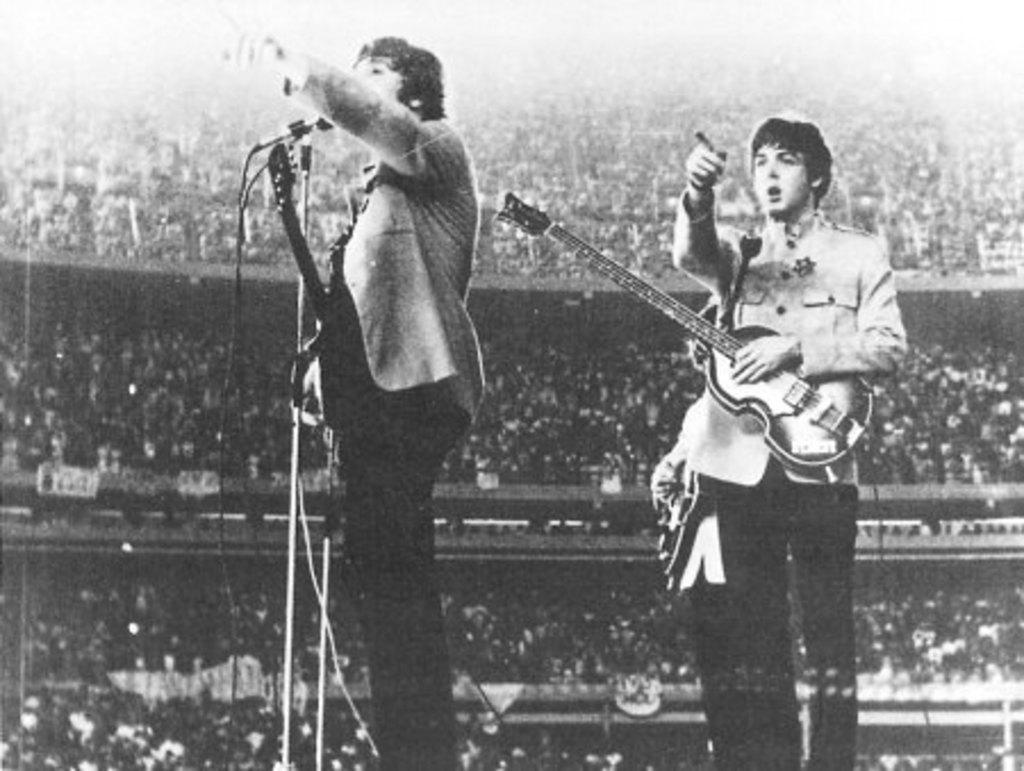How many people are present in the image? There are two persons standing in the image. What are the two persons wearing? Both persons are wearing guitars. What object can be seen near the persons? There is a microphone in the image. Can you describe the setting in which the persons are performing? There is a crowd in the image, suggesting a performance or concert setting. What type of crime is being committed in the image? There is no crime being committed in the image; it features two persons wearing guitars and a microphone, with a crowd present. Can you describe the cloud formation in the image? There is no cloud formation present in the image; it is focused on the persons, microphone, and crowd. 